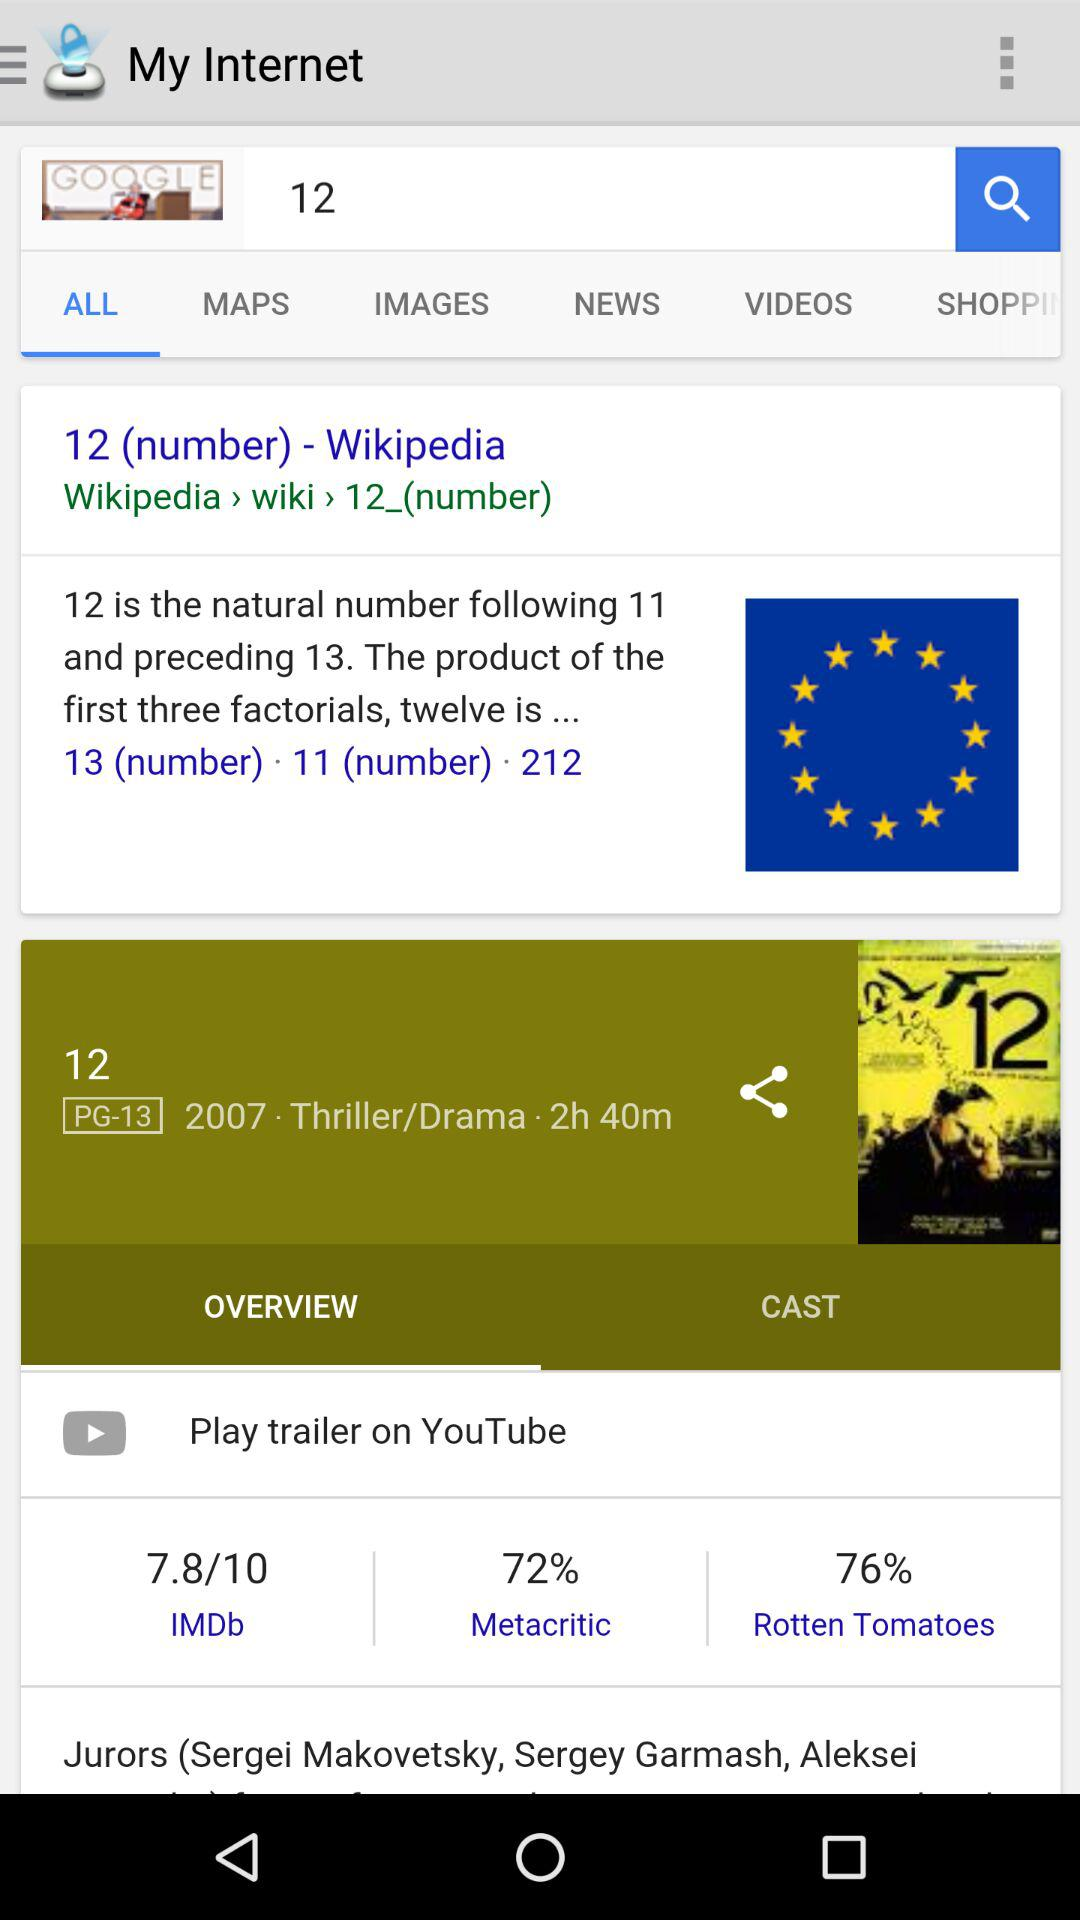What is the name of the application? The name of the application is "My Internet". 